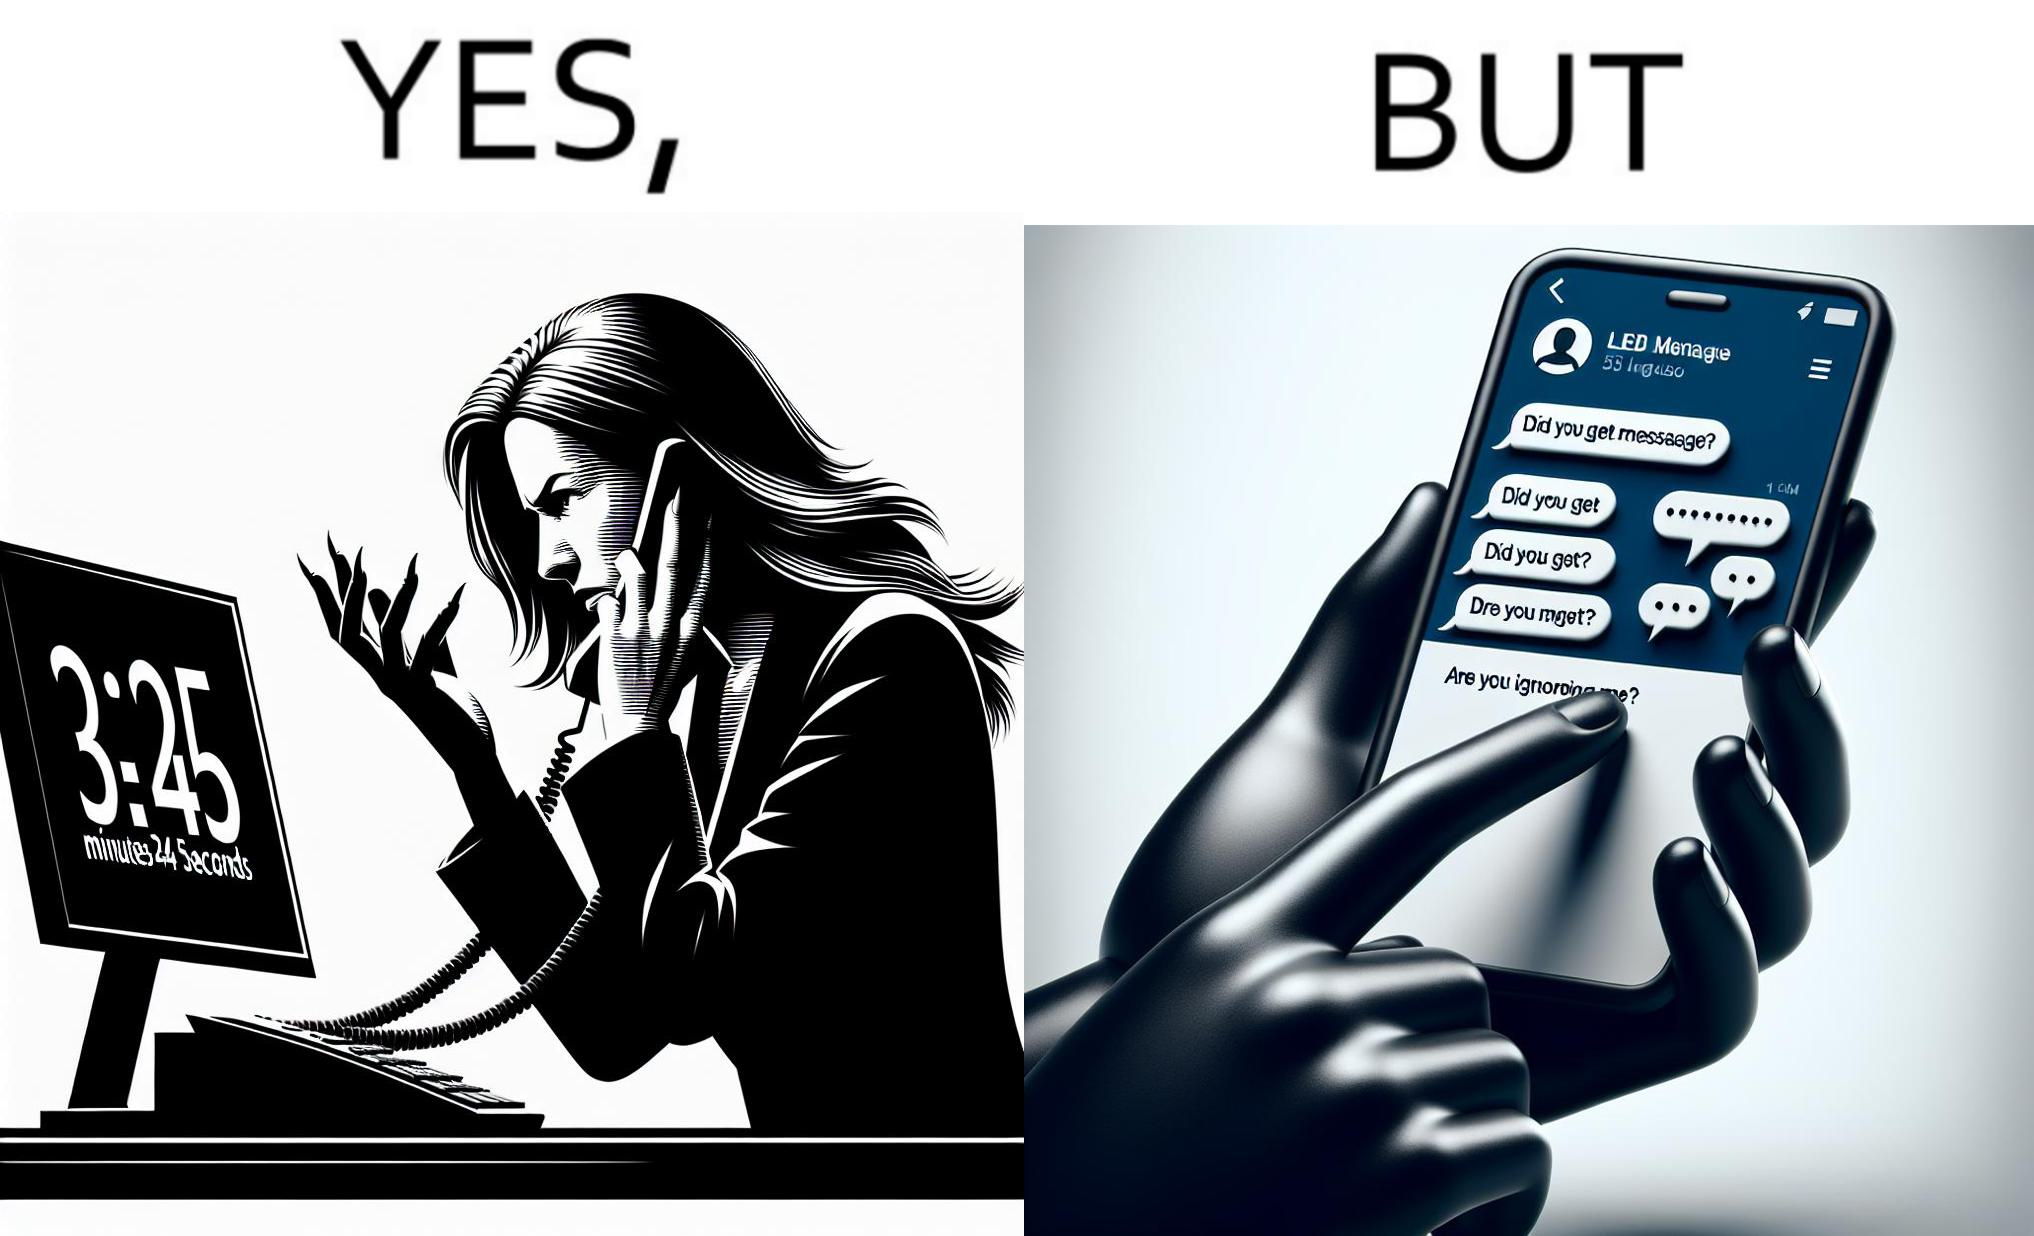What do you see in each half of this image? In the left part of the image: The image shows an annoyed woman talking to the representative in the call center on her mobile phone for over 23 minutes and 45 seconds. In the right part of the image: The image shows the chats of a person on their phone. There are a total of 53 unread chats. In the unanswered chats, the people on the other end are asking if this person got their message or if this person is ignoring them. 